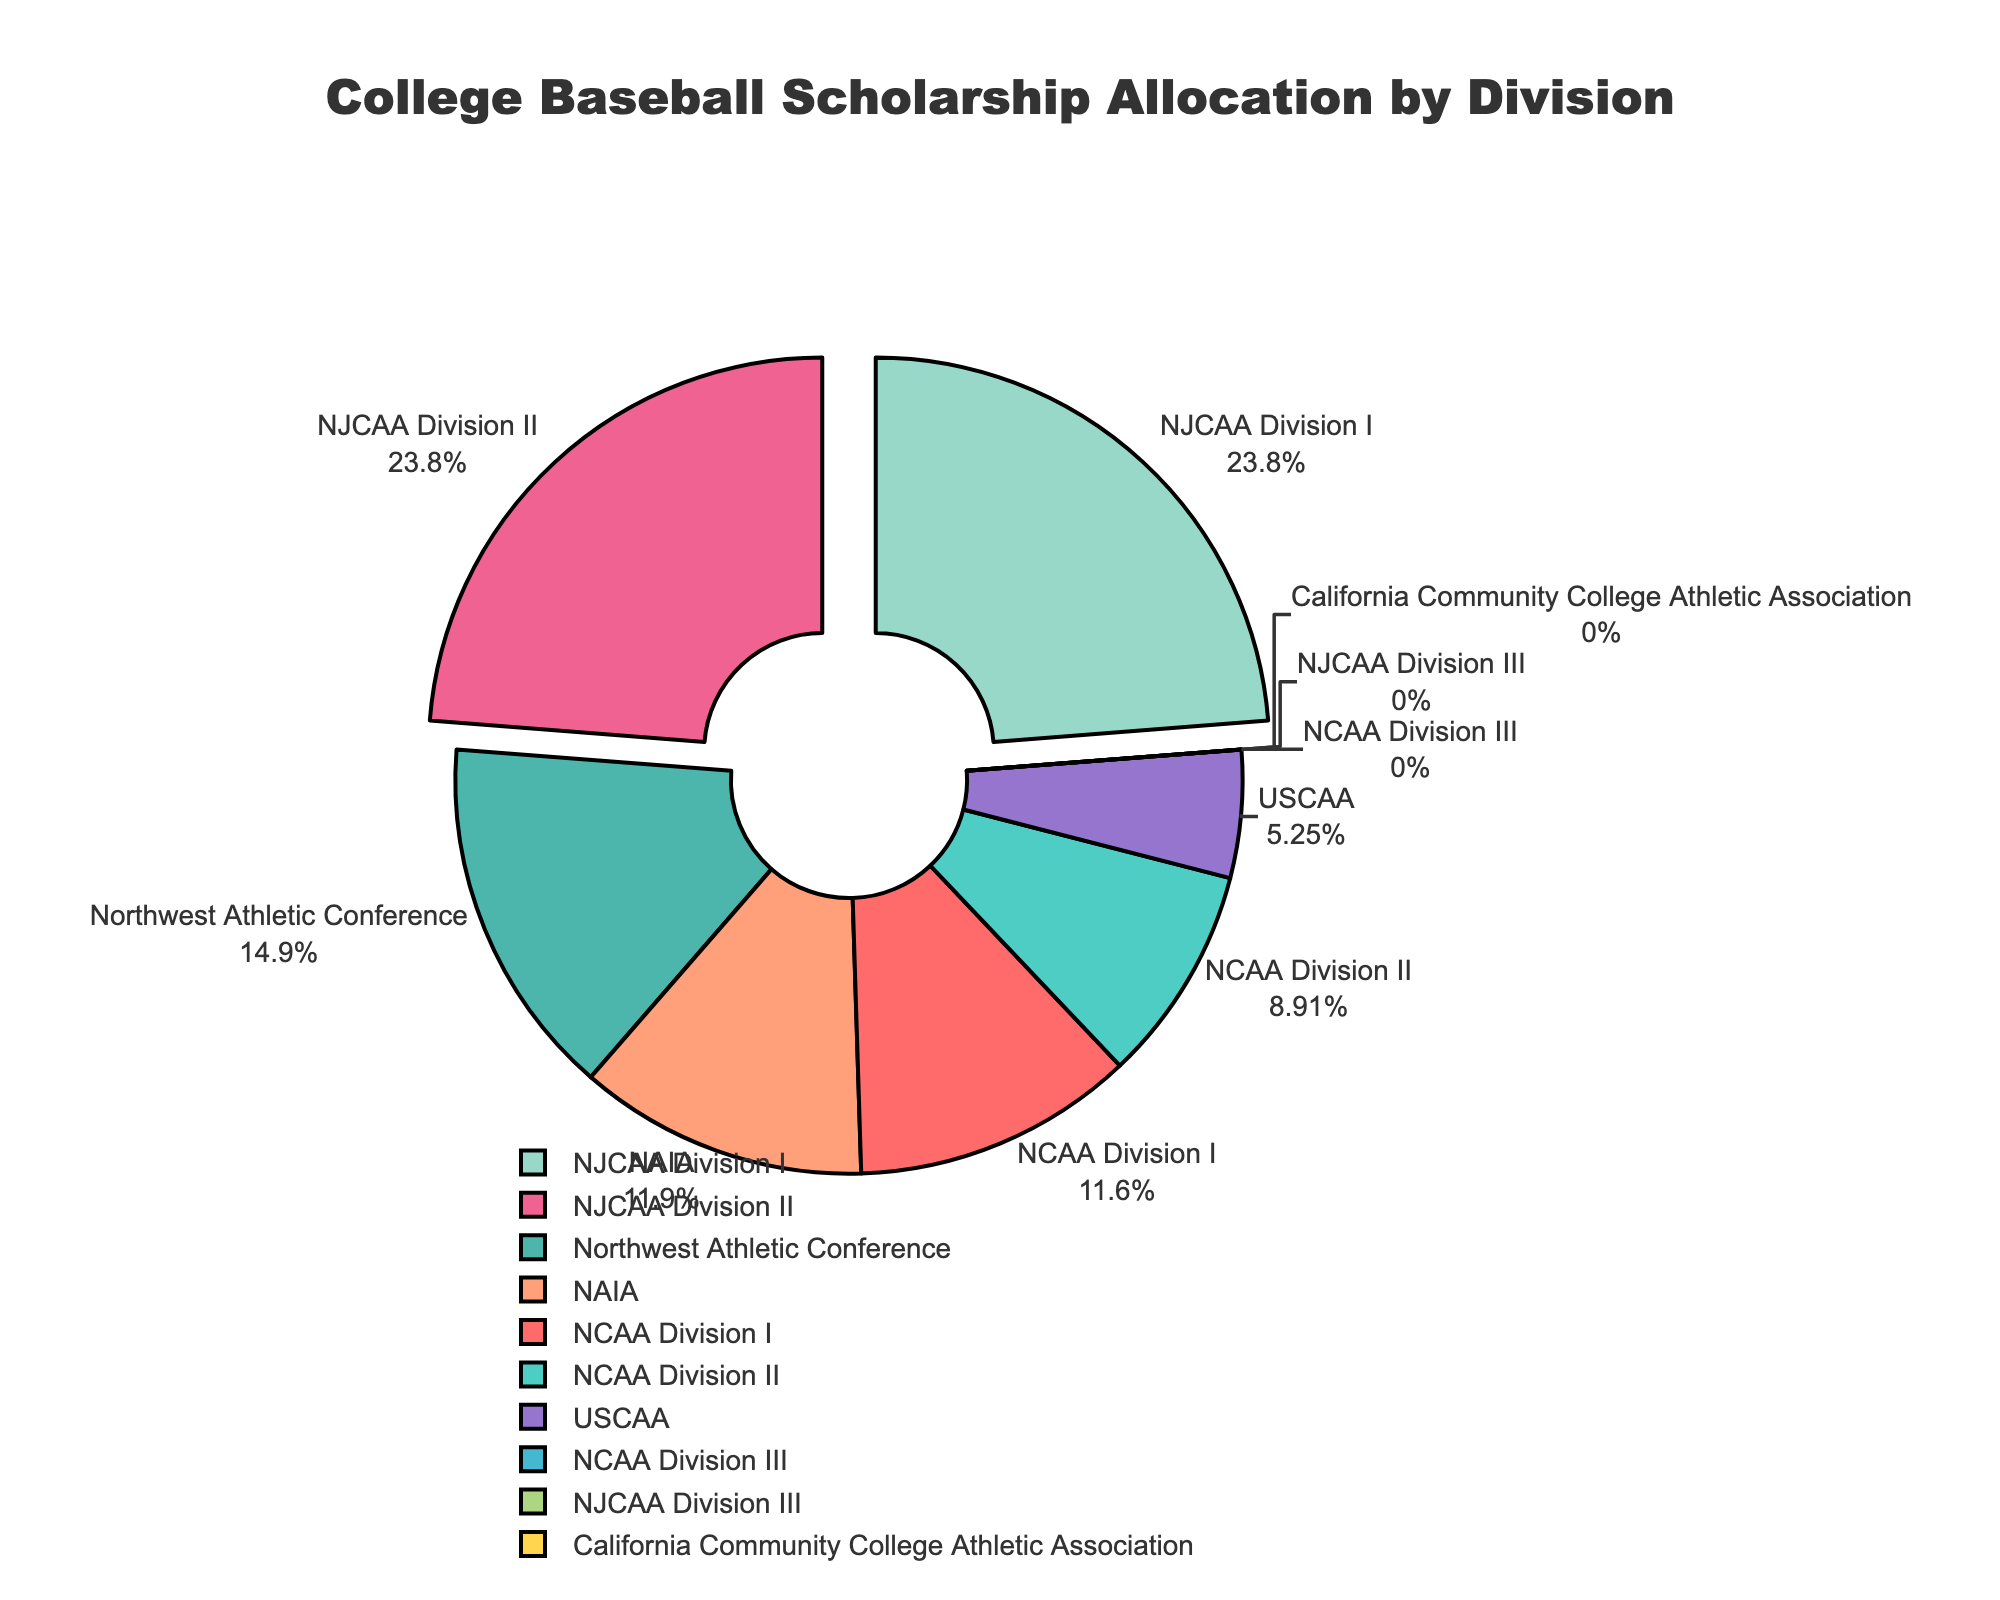What is the largest scholarship allocation percentage in the figure? The figure shows various divisions, and among them, NJCAA Division I and NJCAA Division II both have the highest scholarship allocation percentages at 24.0%.
Answer: 24.0% Which divisions have no scholarship allocation? The divisions with no scholarship allocation are NCAA Division III, NJCAA Division III, and California Community College Athletic Association.
Answer: NCAA Division III, NJCAA Division III, California Community College Athletic Association What is the combined scholarship allocation percentage for NCAA Division I and NCAA Division II? Adding the scholarship allocation percentages for NCAA Division I (11.7%) and NCAA Division II (9.0%) results in 11.7% + 9.0% = 20.7%.
Answer: 20.7% Which division has a higher scholarship allocation: NAIA or Northwest Athletic Conference? Comparing the scholarship allocation percentages, NAIA has 12.0% while Northwest Athletic Conference has 15.0%. Therefore, Northwest Athletic Conference has a higher scholarship allocation.
Answer: Northwest Athletic Conference What is the sum of the scholarship allocation percentages for NJCAA divisions? There are three NJCAA divisions: NJCAA Division I (24.0%), NJCAA Division II (24.0%), and NJCAA Division III (0%). The sum is 24.0% + 24.0% + 0% = 48.0%.
Answer: 48.0% Which divisions are pulled out from the pie chart, and why? The divisions with scholarship allocation percentages greater than 20% are pulled out from the pie chart. These divisions are NJCAA Division I and NJCAA Division II, both with 24.0%.
Answer: NJCAA Division I, NJCAA Division II What color represents NAIA in the pie chart? Looking at the pie chart, NAIA is represented by the color orange.
Answer: Orange What is the total scholarship allocation percentage for all divisions combined? Adding all the scholarship allocation percentages: 11.7% (NCAA Division I) + 9.0% (NCAA Division II) + 0% (NCAA Division III) + 12.0% (NAIA) + 24.0% (NJCAA Division I) + 24.0% (NJCAA Division II) + 0% (NJCAA Division III) + 0% (California Community College Athletic Association) + 15.0% (Northwest Athletic Conference) + 5.3% (USCAA) results in a total of 101.0%.
Answer: 101.0% Does USCAA have a higher scholarship allocation percentage than NCAA Division III? Comparing the figures, USCAA has a scholarship allocation of 5.3% while NCAA Division III has 0%, so USCAA has a higher scholarship allocation.
Answer: Yes What is the average scholarship allocation percentage of divisions with non-zero allocations? To calculate the average: (11.7 + 9.0 + 12.0 + 24.0 + 24.0 + 15.0 + 5.3) / 7 divisions = 101.0 / 7 ≈ 14.43%.
Answer: 14.43% 